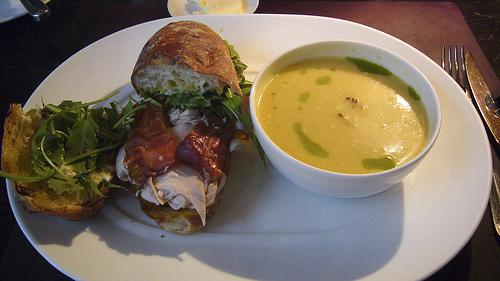Question: where was this picture taken?
Choices:
A. Kitchen.
B. Living room.
C. Dinning room.
D. Near the food.
Answer with the letter. Answer: D Question: what food is shown in the picture?
Choices:
A. Pizza.
B. Pasta.
C. Soup and a sandwich.
D. Steak.
Answer with the letter. Answer: C Question: what metal items are to the right of the plate?
Choices:
A. Cups.
B. Plates.
C. Lighters.
D. Silverware.
Answer with the letter. Answer: D Question: what is this a picture of?
Choices:
A. Zombies.
B. Military.
C. Food.
D. Puppies.
Answer with the letter. Answer: C Question: why was this photo taken?
Choices:
A. For art.
B. Memories.
C. Proof of work.
D. Savory food.
Answer with the letter. Answer: D 